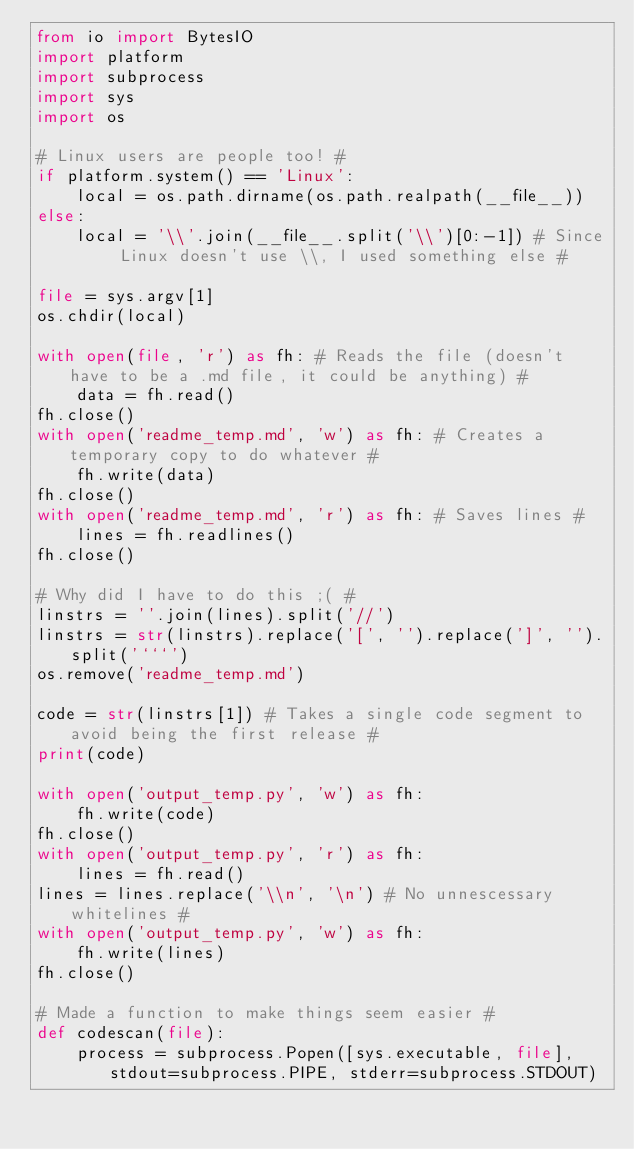<code> <loc_0><loc_0><loc_500><loc_500><_Python_>from io import BytesIO
import platform
import subprocess
import sys
import os

# Linux users are people too! #
if platform.system() == 'Linux':
    local = os.path.dirname(os.path.realpath(__file__)) 
else:
    local = '\\'.join(__file__.split('\\')[0:-1]) # Since Linux doesn't use \\, I used something else #

file = sys.argv[1]
os.chdir(local)

with open(file, 'r') as fh: # Reads the file (doesn't have to be a .md file, it could be anything) #
    data = fh.read()
fh.close()
with open('readme_temp.md', 'w') as fh: # Creates a temporary copy to do whatever #
    fh.write(data)
fh.close()
with open('readme_temp.md', 'r') as fh: # Saves lines #
    lines = fh.readlines()
fh.close()

# Why did I have to do this ;( #
linstrs = ''.join(lines).split('//')
linstrs = str(linstrs).replace('[', '').replace(']', '').split('```')
os.remove('readme_temp.md')

code = str(linstrs[1]) # Takes a single code segment to avoid being the first release #
print(code)

with open('output_temp.py', 'w') as fh:
    fh.write(code)
fh.close()
with open('output_temp.py', 'r') as fh:
    lines = fh.read()
lines = lines.replace('\\n', '\n') # No unnescessary whitelines #
with open('output_temp.py', 'w') as fh:
    fh.write(lines)
fh.close()

# Made a function to make things seem easier #
def codescan(file):
    process = subprocess.Popen([sys.executable, file], stdout=subprocess.PIPE, stderr=subprocess.STDOUT)</code> 